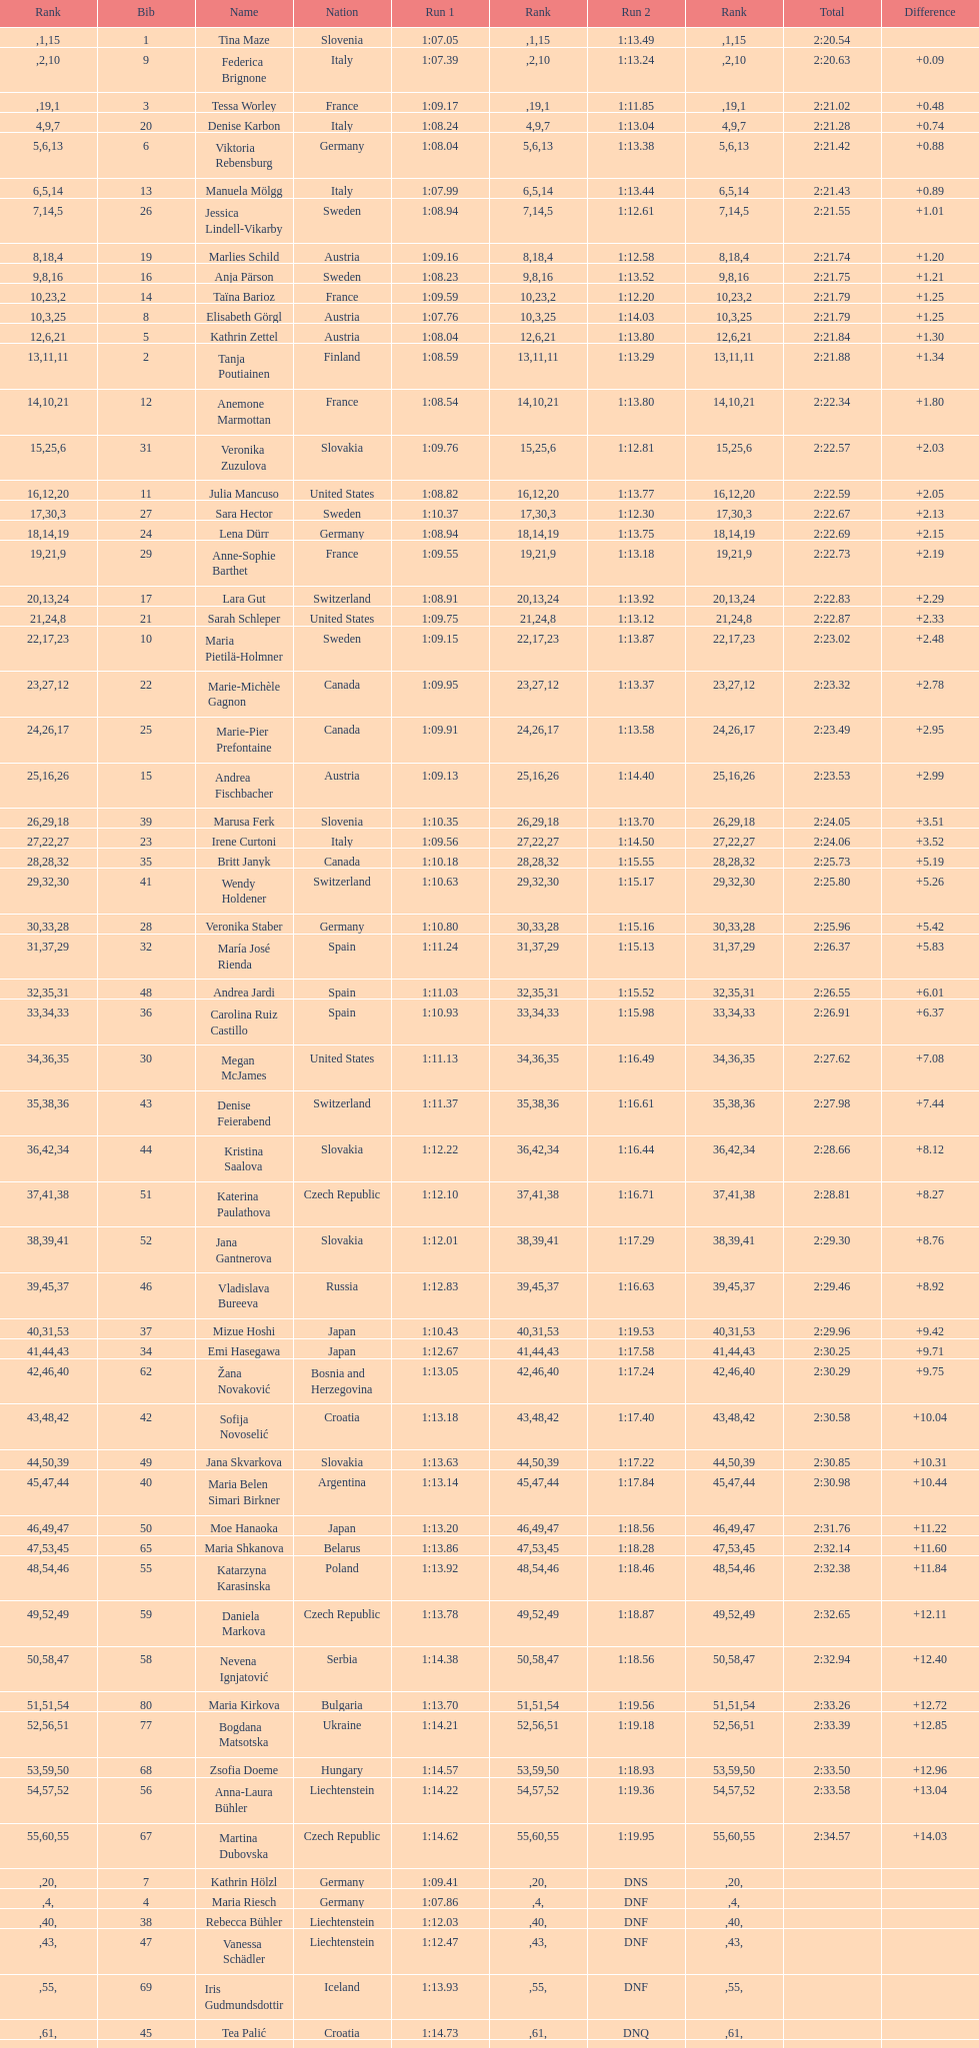Who ranked next after federica brignone? Tessa Worley. 